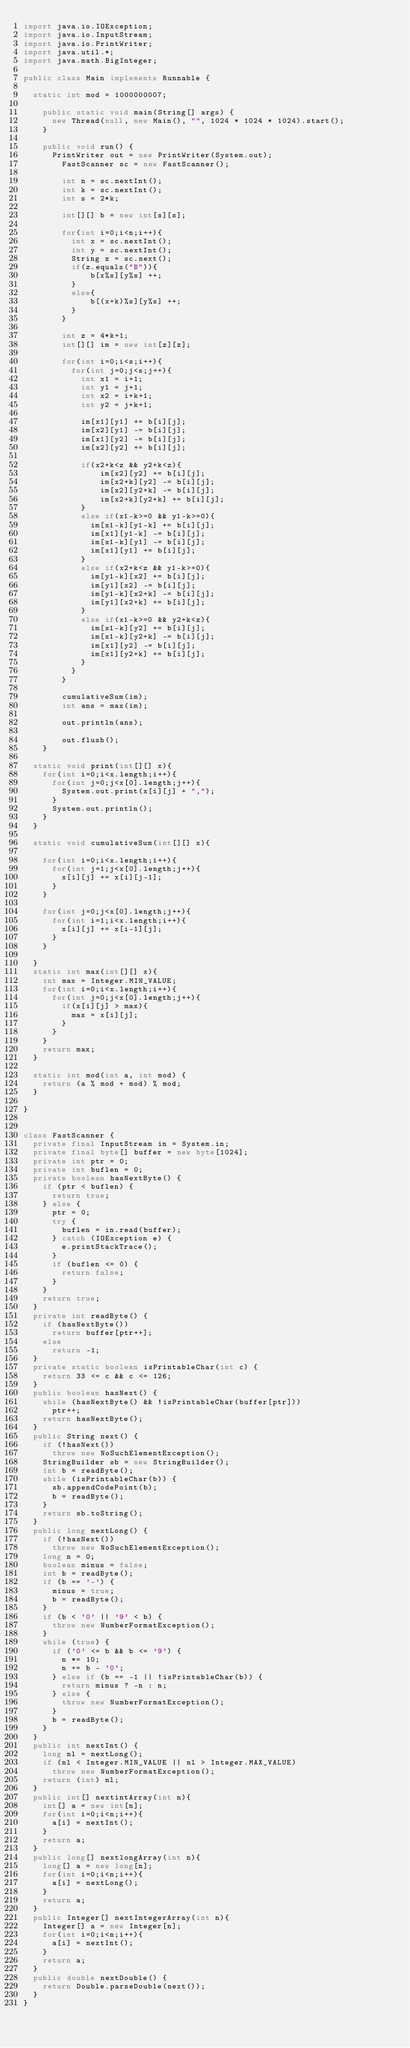Convert code to text. <code><loc_0><loc_0><loc_500><loc_500><_Java_>import java.io.IOException;
import java.io.InputStream;
import java.io.PrintWriter;
import java.util.*;
import java.math.BigInteger;
 
public class Main implements Runnable {
	
	static int mod = 1000000007;
	
    public static void main(String[] args) {
    	new Thread(null, new Main(), "", 1024 * 1024 * 1024).start();
    }
    
    public void run() {
    	PrintWriter out = new PrintWriter(System.out);
        FastScanner sc = new FastScanner();
        
        int n = sc.nextInt();
        int k = sc.nextInt();
        int s = 2*k;
        
        int[][] b = new int[s][s];
        
        for(int i=0;i<n;i++){
        	int x = sc.nextInt();
        	int y = sc.nextInt();
        	String z = sc.next();
        	if(z.equals("B")){
            	b[x%s][y%s] ++;
        	}
        	else{
            	b[(x+k)%s][y%s] ++;
        	}
        }
        
        int z = 4*k+1;
        int[][] im = new int[z][z];

        for(int i=0;i<s;i++){
        	for(int j=0;j<s;j++){
        		int x1 = i+1;
        		int y1 = j+1;
        		int x2 = i+k+1;
        		int y2 = j+k+1;
        		
        		im[x1][y1] += b[i][j];
        		im[x2][y1] -= b[i][j];
        		im[x1][y2] -= b[i][j];
        		im[x2][y2] += b[i][j];
        		
        		if(x2+k<z && y2+k<z){
            		im[x2][y2] += b[i][j];
            		im[x2+k][y2] -= b[i][j];
            		im[x2][y2+k] -= b[i][j];
            		im[x2+k][y2+k] += b[i][j];
        		}
        		else if(x1-k>=0 && y1-k>=0){
        			im[x1-k][y1-k] += b[i][j];
        			im[x1][y1-k] -= b[i][j];
        			im[x1-k][y1] -= b[i][j];
        			im[x1][y1] += b[i][j];
        		}
        		else if(x2+k<z && y1-k>=0){
        			im[y1-k][x2] += b[i][j];
        			im[y1][x2] -= b[i][j];
        			im[y1-k][x2+k] -= b[i][j];
        			im[y1][x2+k] += b[i][j];
        		}
        		else if(x1-k>=0 && y2+k<z){
        			im[x1-k][y2] += b[i][j];
        			im[x1-k][y2+k] -= b[i][j];
        			im[x1][y2] -= b[i][j];
        			im[x1][y2+k] += b[i][j];
        		}
        	}
        }
        
        cumulativeSum(im);
        int ans = max(im);
        
        out.println(ans);
        
        out.flush();
    }
    
	static void print(int[][] x){
		for(int i=0;i<x.length;i++){
			for(int j=0;j<x[0].length;j++){
				System.out.print(x[i][j] + ",");
			}
			System.out.println();
		}
	}
    
	static void cumulativeSum(int[][] x){

		for(int i=0;i<x.length;i++){
			for(int j=1;j<x[0].length;j++){
				x[i][j] += x[i][j-1];
			}
		}
		
		for(int j=0;j<x[0].length;j++){
			for(int i=1;i<x.length;i++){
				x[i][j] += x[i-1][j];
			}
		}
		
	}
	static int max(int[][] x){
		int max = Integer.MIN_VALUE;
		for(int i=0;i<x.length;i++){
			for(int j=0;j<x[0].length;j++){
				if(x[i][j] > max){
					max = x[i][j];
				}
			}
		}
		return max;
	}
	
	static int mod(int a, int mod) {
		return (a % mod + mod) % mod;
	}

}


class FastScanner {
	private final InputStream in = System.in;
	private final byte[] buffer = new byte[1024];
	private int ptr = 0;
	private int buflen = 0;
	private boolean hasNextByte() {
		if (ptr < buflen) {
			return true;
		} else {
			ptr = 0;
			try {
				buflen = in.read(buffer);
			} catch (IOException e) {
				e.printStackTrace();
			}
			if (buflen <= 0) {
				return false;
			}
		}
		return true;
	}
	private int readByte() {
		if (hasNextByte())
			return buffer[ptr++];
		else
			return -1;
	}
	private static boolean isPrintableChar(int c) {
		return 33 <= c && c <= 126;
	}
	public boolean hasNext() {
		while (hasNextByte() && !isPrintableChar(buffer[ptr]))
			ptr++;
		return hasNextByte();
	}
	public String next() {
		if (!hasNext())
			throw new NoSuchElementException();
		StringBuilder sb = new StringBuilder();
		int b = readByte();
		while (isPrintableChar(b)) {
			sb.appendCodePoint(b);
			b = readByte();
		}
		return sb.toString();
	}
	public long nextLong() {
		if (!hasNext())
			throw new NoSuchElementException();
		long n = 0;
		boolean minus = false;
		int b = readByte();
		if (b == '-') {
			minus = true;
			b = readByte();
		}
		if (b < '0' || '9' < b) {
			throw new NumberFormatException();
		}
		while (true) {
			if ('0' <= b && b <= '9') {
				n *= 10;
				n += b - '0';
			} else if (b == -1 || !isPrintableChar(b)) {
				return minus ? -n : n;
			} else {
				throw new NumberFormatException();
			}
			b = readByte();
		}
	}
	public int nextInt() {
		long nl = nextLong();
		if (nl < Integer.MIN_VALUE || nl > Integer.MAX_VALUE)
			throw new NumberFormatException();
		return (int) nl;
	}
	public int[] nextintArray(int n){
		int[] a = new int[n];
		for(int i=0;i<n;i++){
			a[i] = nextInt();
		}
		return a;
	}
	public long[] nextlongArray(int n){
		long[] a = new long[n];
		for(int i=0;i<n;i++){
			a[i] = nextLong();
		}
		return a;
	}
	public Integer[] nextIntegerArray(int n){
		Integer[] a = new Integer[n];
		for(int i=0;i<n;i++){
			a[i] = nextInt();
		}
		return a;
	}
	public double nextDouble() {
		return Double.parseDouble(next());
	}
}</code> 